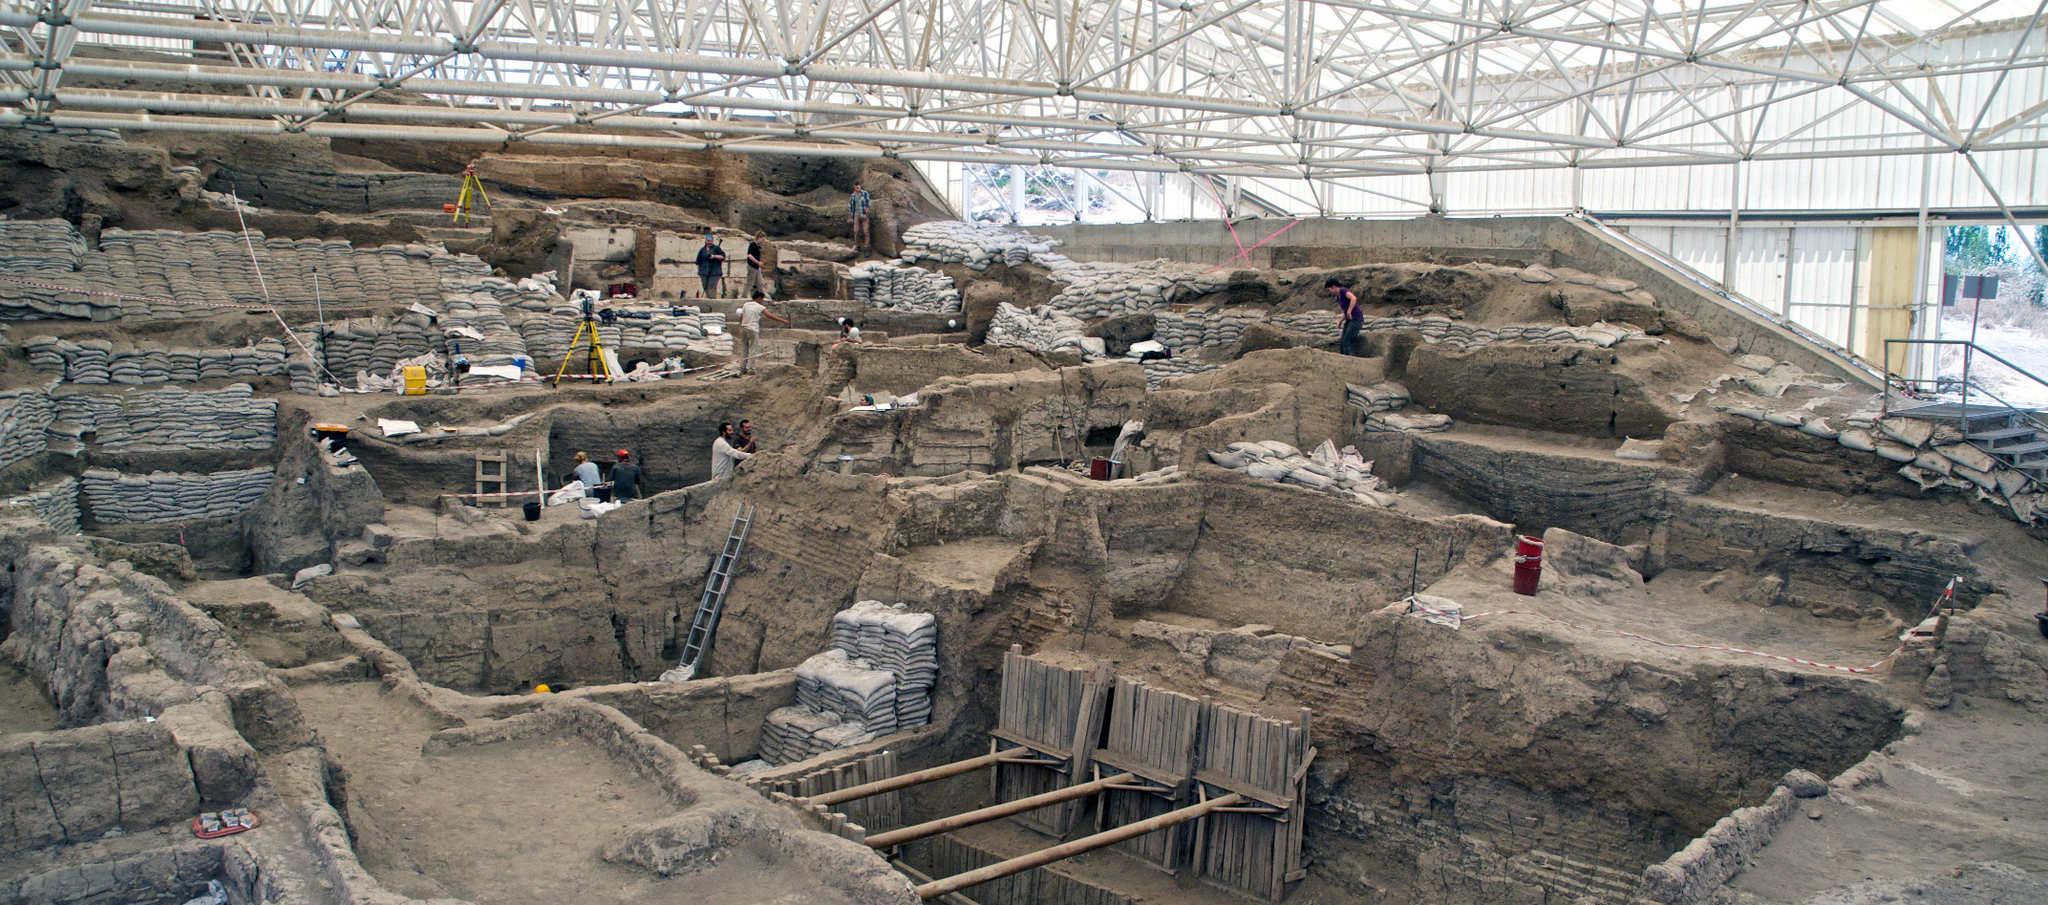What might these ruins have looked like in their prime, bustling with people? In their prime, the ruins of Çatalhöyük would have been a thriving settlement, bustling with activity. You might envision densely packed mud-brick houses, with flat rooftops serving as additional living spaces where families gathered, worked, and relaxed. Narrow alleyways would have weaved between the structures, filled with the sounds of children playing, artisans crafting their goods, and traders exchanging goods. Smoke from cooking fires would rise from the rooftops and mingle with the scent of fresh bread, herbs, and perhaps roasting meat. Colorful murals and decorations would adorn the walls, reflecting cultural and spiritual life. Communal spaces would be vibrant with social interactions and collective activities, fostering a strong sense of community among the inhabitants. What kind of daily activities would the ancient people of Çatalhöyük be engaged in? The daily activities of the people living in Çatalhöyük would have been varied and closely tied to their environment and societal structure. Individuals would start their day early, engaging in tasks such as farming, hunting, and gathering to procure food. Others might be involved in crafting pottery, weaving textiles, or knapping flint to create tools and weapons. Social and religious activities would play a significant role, with communal gatherings, rituals, and feasts being common occurrences. Trade with neighboring communities would provide additional resources and foster cultural exchanges. The focus would be on maintaining the well-being and sustainability of their community through cooperation and shared responsibilities. Assume you're an archaeologist who just found a unique artifact at this site. How would you document and analyze it? As an archaeologist discovering a unique artifact at Çatalhöyük, the first step would be to document its exact location and context within the site. This involves taking detailed photographs, making sketches, and noting its stratigraphic layer. The artifact would then be carefully cleaned and preserved to prevent any damage. Measurements and descriptions of its size, shape, material, and any distinctive features would be recorded. Next, the artifact would undergo various analyses, such as material composition tests and dating methods like radiocarbon dating, to determine its age and origin. Comparisons with similar findings would help infer its possible uses and cultural significance. Finally, the artifact would be cataloged and, if particularly significant, prepared for display in a museum or included in academic publications to contribute to the broader understanding of Çatalhöyük’s history. 